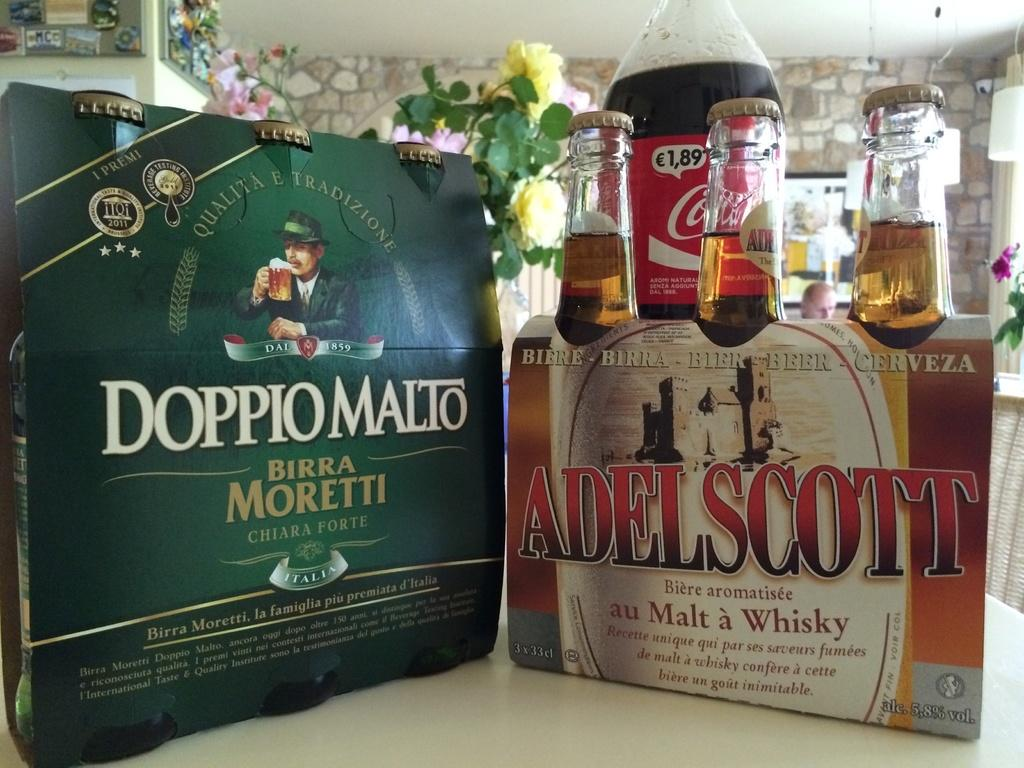<image>
Provide a brief description of the given image. Full cases of Doppio Malto and Adelscott beer sit on a countertop. 